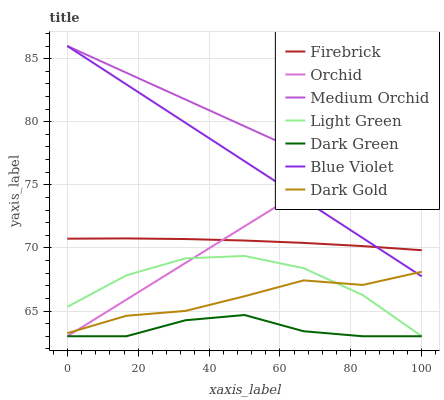Does Firebrick have the minimum area under the curve?
Answer yes or no. No. Does Firebrick have the maximum area under the curve?
Answer yes or no. No. Is Firebrick the smoothest?
Answer yes or no. No. Is Firebrick the roughest?
Answer yes or no. No. Does Firebrick have the lowest value?
Answer yes or no. No. Does Firebrick have the highest value?
Answer yes or no. No. Is Light Green less than Blue Violet?
Answer yes or no. Yes. Is Medium Orchid greater than Firebrick?
Answer yes or no. Yes. Does Light Green intersect Blue Violet?
Answer yes or no. No. 